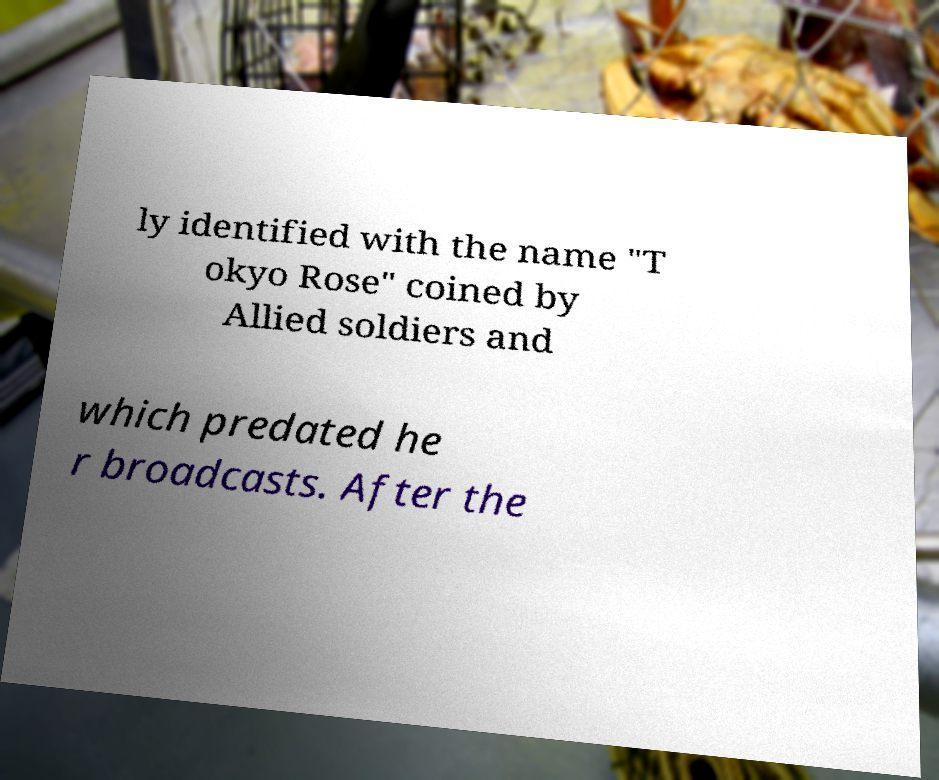Can you accurately transcribe the text from the provided image for me? ly identified with the name "T okyo Rose" coined by Allied soldiers and which predated he r broadcasts. After the 